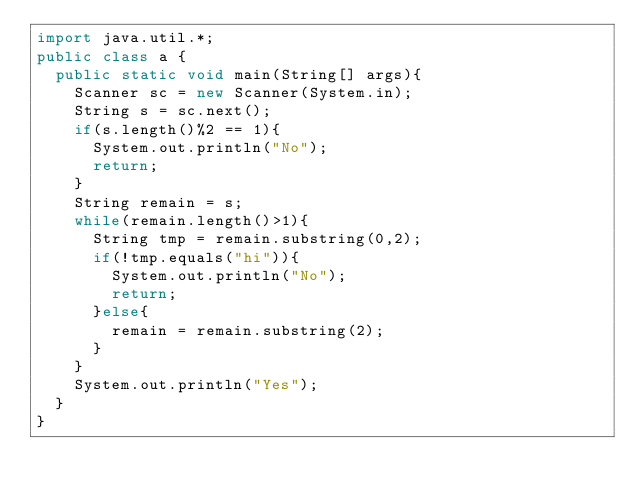<code> <loc_0><loc_0><loc_500><loc_500><_Java_>import java.util.*;
public class a {
	public static void main(String[] args){
		Scanner sc = new Scanner(System.in);
		String s = sc.next();
		if(s.length()%2 == 1){
			System.out.println("No");
			return;
		}
		String remain = s;
		while(remain.length()>1){
			String tmp = remain.substring(0,2);
			if(!tmp.equals("hi")){
				System.out.println("No");
				return;
			}else{
				remain = remain.substring(2);
			}
		}
		System.out.println("Yes");
	}
}</code> 